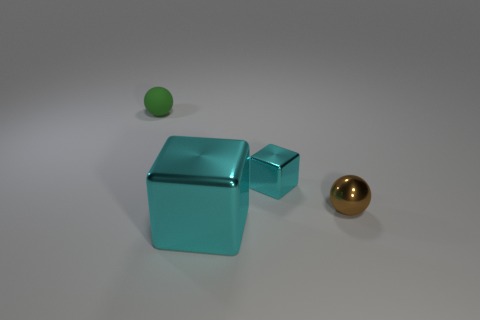Is there any other thing that is the same material as the green object?
Your answer should be compact. No. There is a thing that is both left of the tiny cyan shiny thing and behind the small brown ball; what material is it?
Offer a very short reply. Rubber. What color is the tiny cube?
Provide a succinct answer. Cyan. How many brown shiny objects are the same shape as the small green rubber object?
Provide a succinct answer. 1. Is the ball in front of the rubber object made of the same material as the small object behind the tiny cyan metallic object?
Ensure brevity in your answer.  No. There is a block that is behind the tiny sphere that is in front of the tiny green thing; how big is it?
Offer a very short reply. Small. What material is the other tiny brown object that is the same shape as the small matte object?
Provide a short and direct response. Metal. There is a cyan object behind the brown metal sphere; is it the same shape as the big cyan object that is in front of the brown thing?
Your answer should be compact. Yes. Is the number of big metallic objects greater than the number of small red spheres?
Provide a short and direct response. Yes. What size is the rubber thing?
Make the answer very short. Small. 